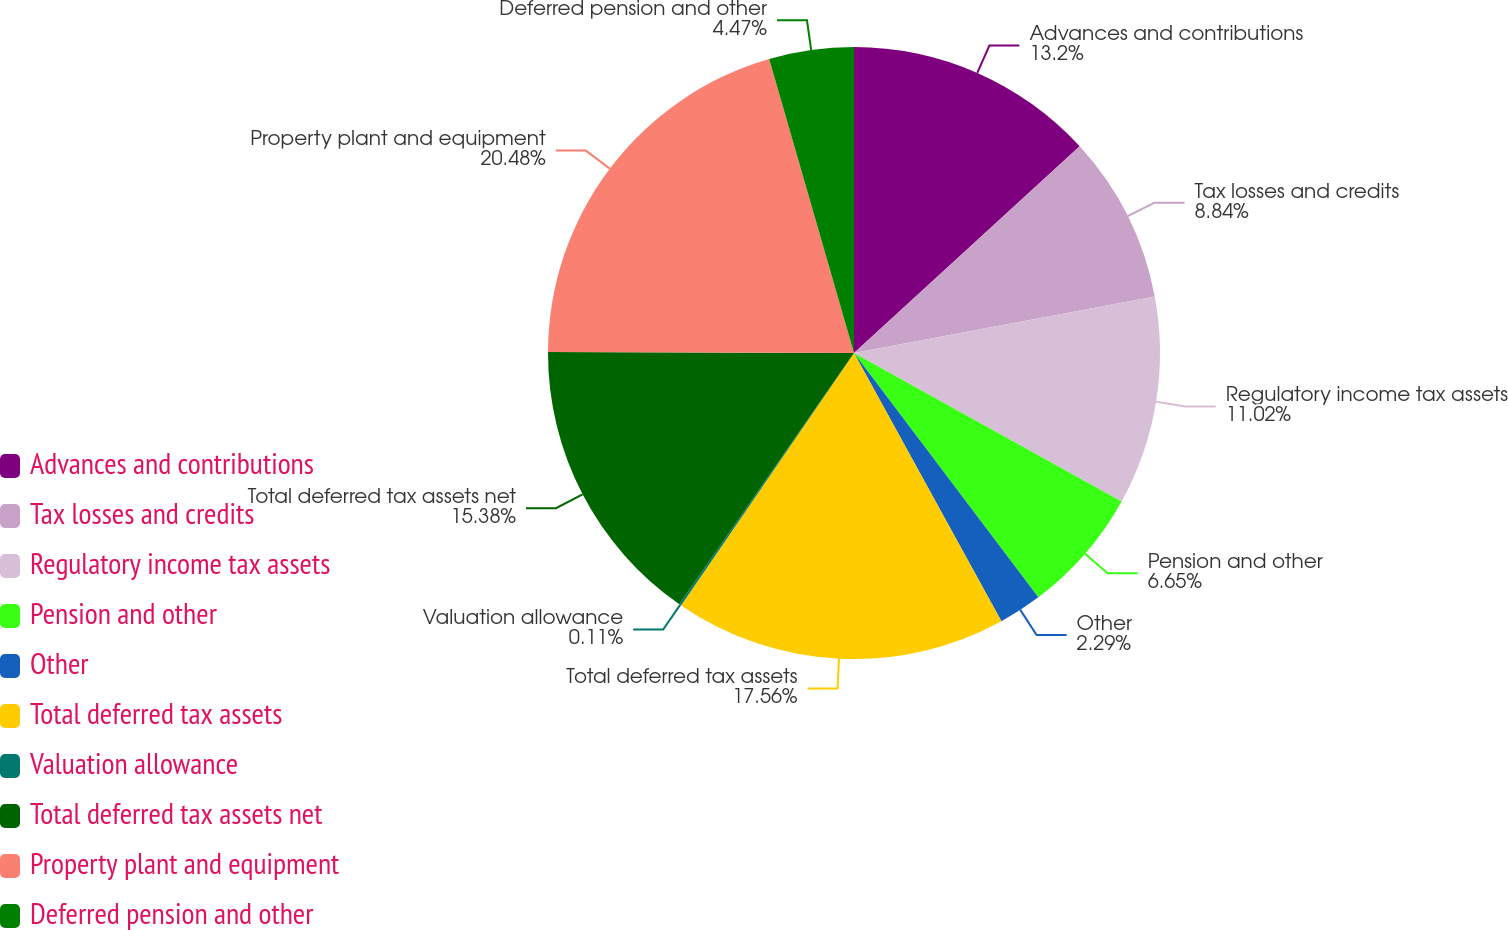Convert chart. <chart><loc_0><loc_0><loc_500><loc_500><pie_chart><fcel>Advances and contributions<fcel>Tax losses and credits<fcel>Regulatory income tax assets<fcel>Pension and other<fcel>Other<fcel>Total deferred tax assets<fcel>Valuation allowance<fcel>Total deferred tax assets net<fcel>Property plant and equipment<fcel>Deferred pension and other<nl><fcel>13.2%<fcel>8.84%<fcel>11.02%<fcel>6.65%<fcel>2.29%<fcel>17.56%<fcel>0.11%<fcel>15.38%<fcel>20.48%<fcel>4.47%<nl></chart> 